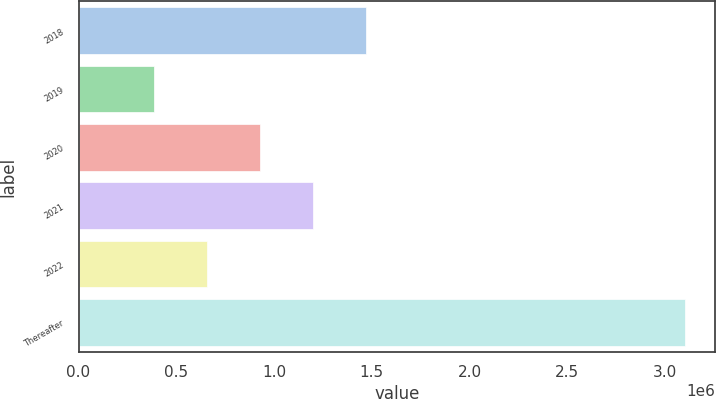<chart> <loc_0><loc_0><loc_500><loc_500><bar_chart><fcel>2018<fcel>2019<fcel>2020<fcel>2021<fcel>2022<fcel>Thereafter<nl><fcel>1.47286e+06<fcel>386564<fcel>929713<fcel>1.20129e+06<fcel>658138<fcel>3.10231e+06<nl></chart> 